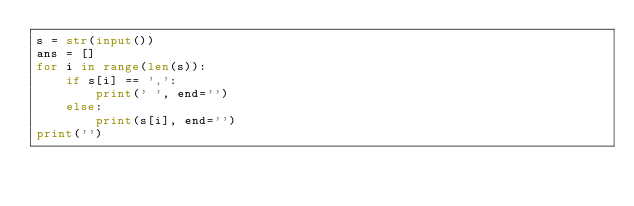<code> <loc_0><loc_0><loc_500><loc_500><_Python_>s = str(input())
ans = []
for i in range(len(s)):
    if s[i] == ',':
        print(' ', end='')
    else:
        print(s[i], end='')
print('')</code> 